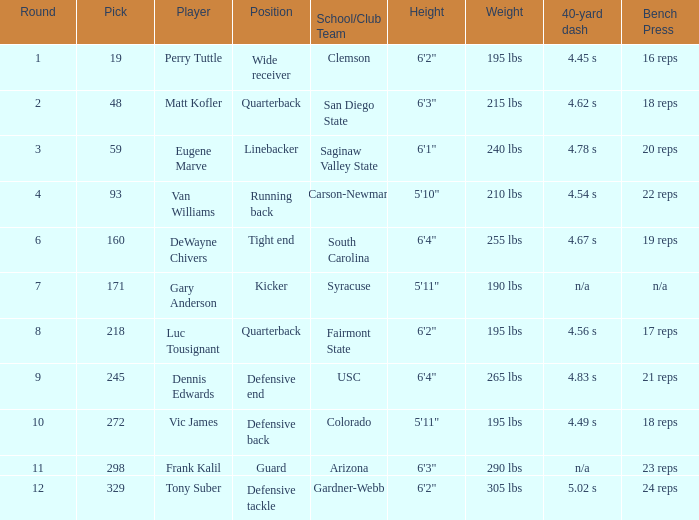Which player's pick is 160? DeWayne Chivers. 